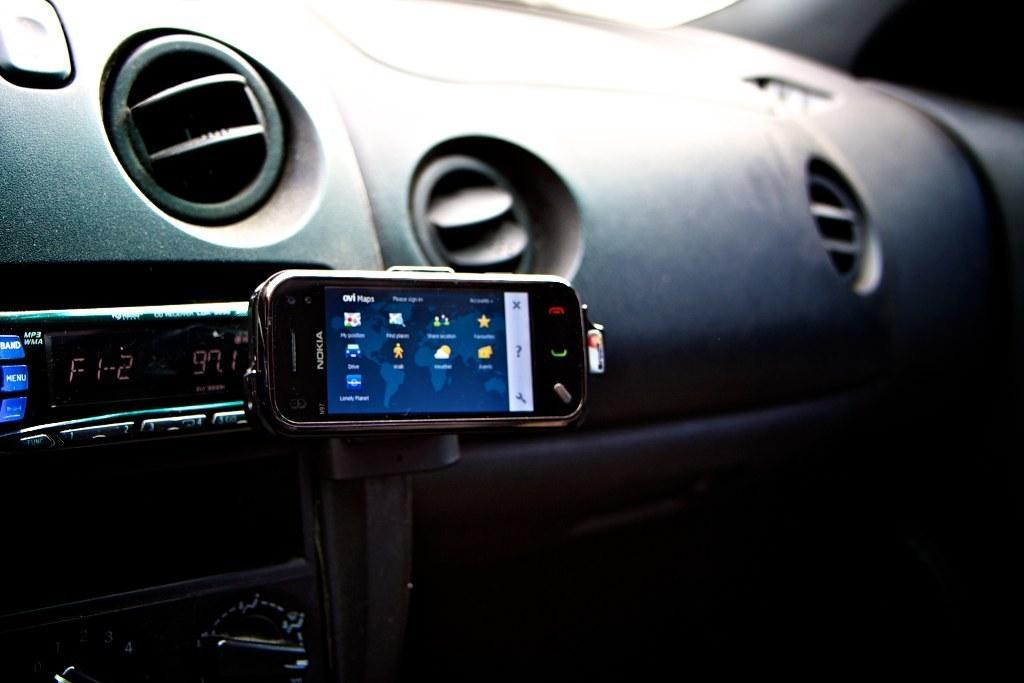Can you describe this image briefly? In this image I can see the dashboard of the car which is black in color. I can see the mobile which is black in color to the dashboard. I can see the sound system and few buttons. 